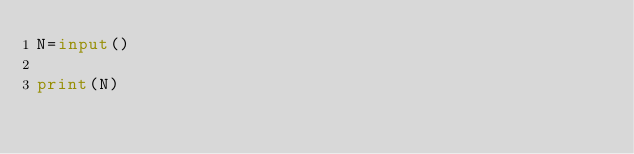Convert code to text. <code><loc_0><loc_0><loc_500><loc_500><_Python_>N=input()

print(N)</code> 